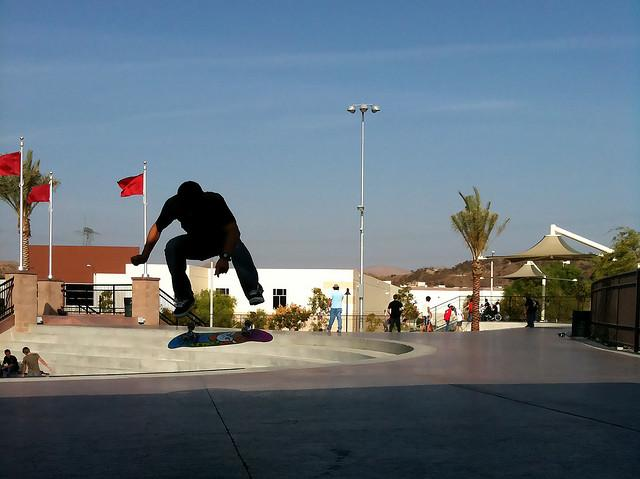What action is he taking with the board?

Choices:
A) bounce
B) throw
C) kick
D) flip flip 